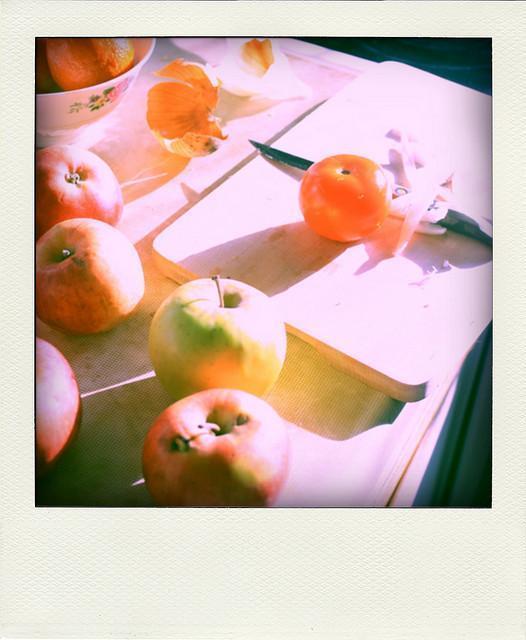How many apples are there?
Give a very brief answer. 4. How many people are in this picture?
Give a very brief answer. 0. 